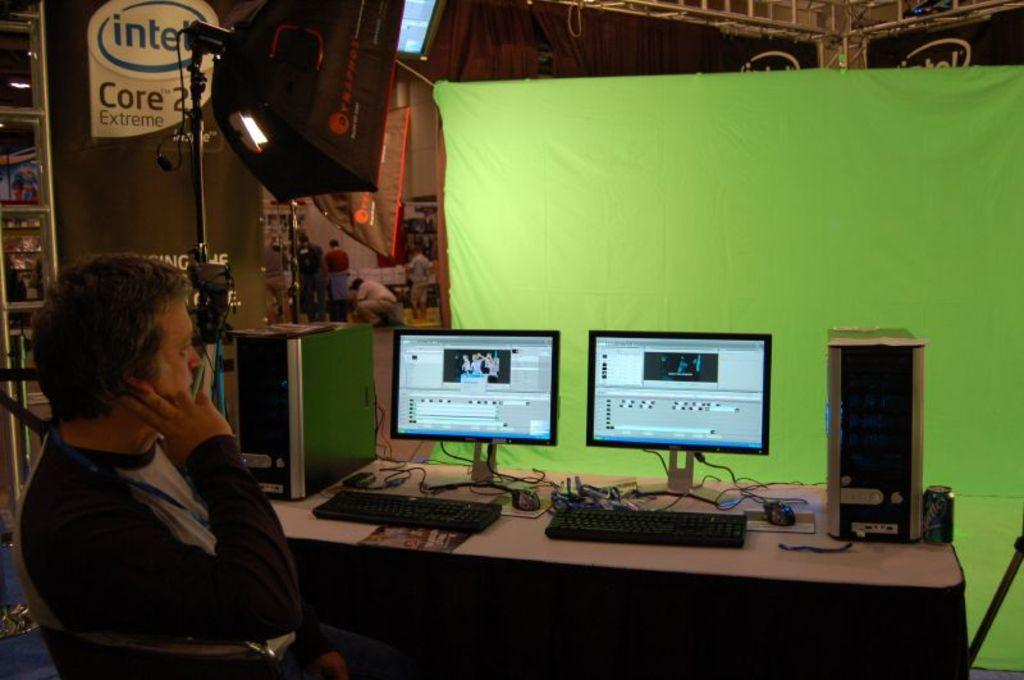<image>
Describe the image concisely. A green screen behind some monitors with an Intel poster on the wall. 